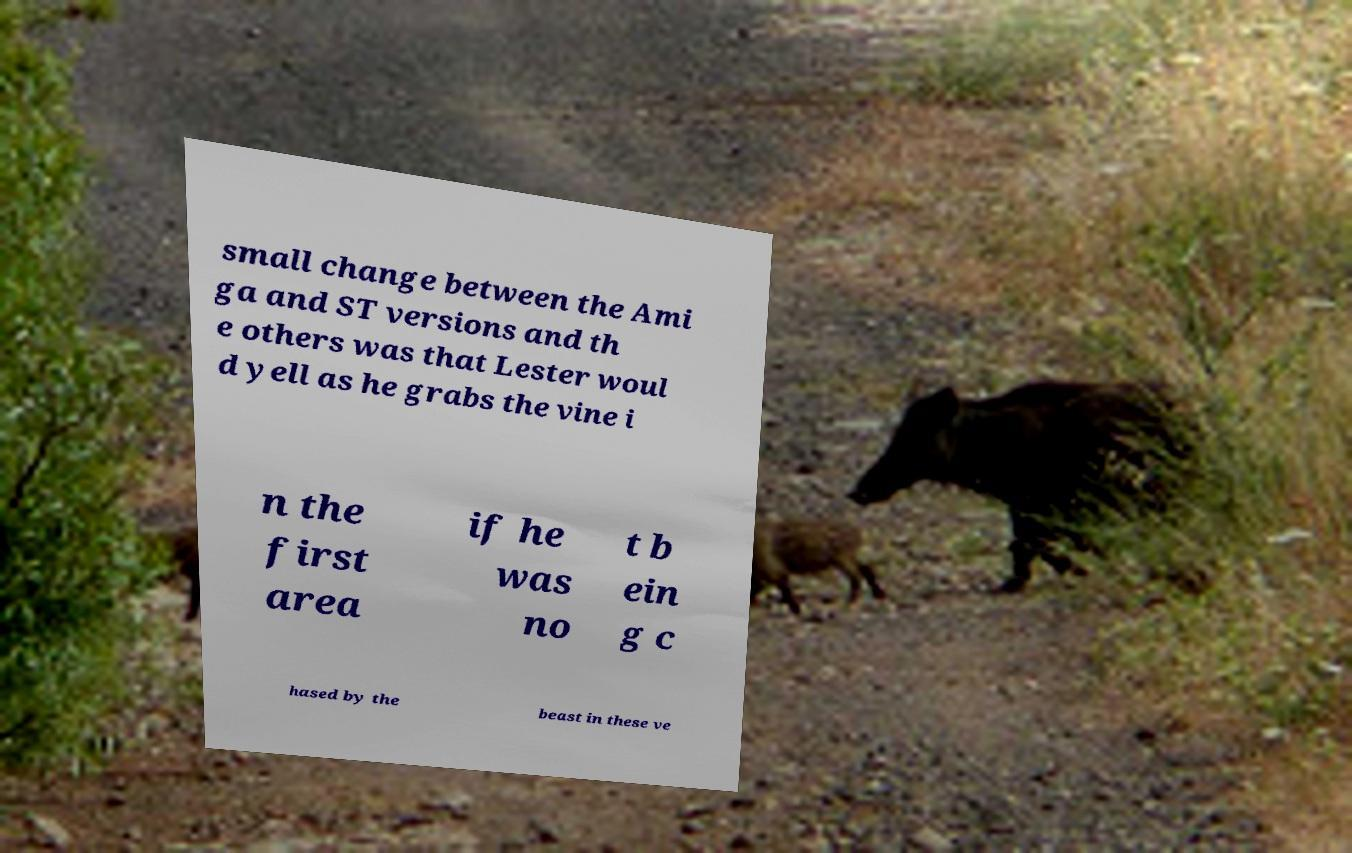Could you assist in decoding the text presented in this image and type it out clearly? small change between the Ami ga and ST versions and th e others was that Lester woul d yell as he grabs the vine i n the first area if he was no t b ein g c hased by the beast in these ve 